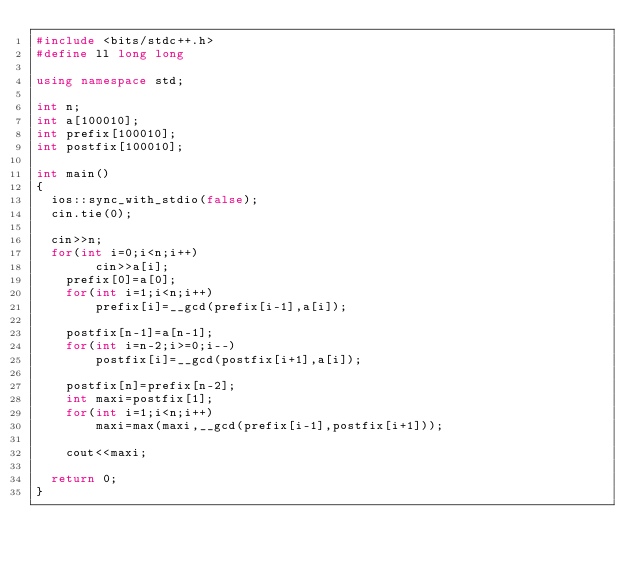<code> <loc_0><loc_0><loc_500><loc_500><_C++_>#include <bits/stdc++.h>
#define ll long long

using namespace std;

int n;
int a[100010];
int prefix[100010];
int postfix[100010];

int main()
{
	ios::sync_with_stdio(false);
	cin.tie(0);

	cin>>n;
	for(int i=0;i<n;i++)
        cin>>a[i];
    prefix[0]=a[0];
    for(int i=1;i<n;i++)
        prefix[i]=__gcd(prefix[i-1],a[i]);

    postfix[n-1]=a[n-1];
    for(int i=n-2;i>=0;i--)
        postfix[i]=__gcd(postfix[i+1],a[i]);

    postfix[n]=prefix[n-2];
    int maxi=postfix[1];
    for(int i=1;i<n;i++)
        maxi=max(maxi,__gcd(prefix[i-1],postfix[i+1]));

    cout<<maxi;

	return 0;
}
</code> 